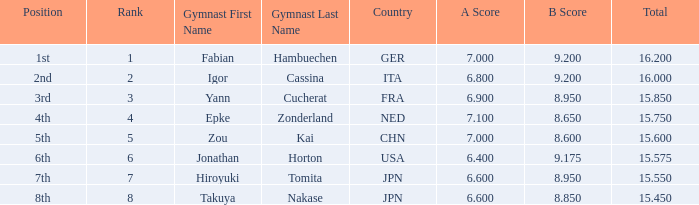What was the total rating that had a score higher than 7 and a b score smaller than 8.65? None. 